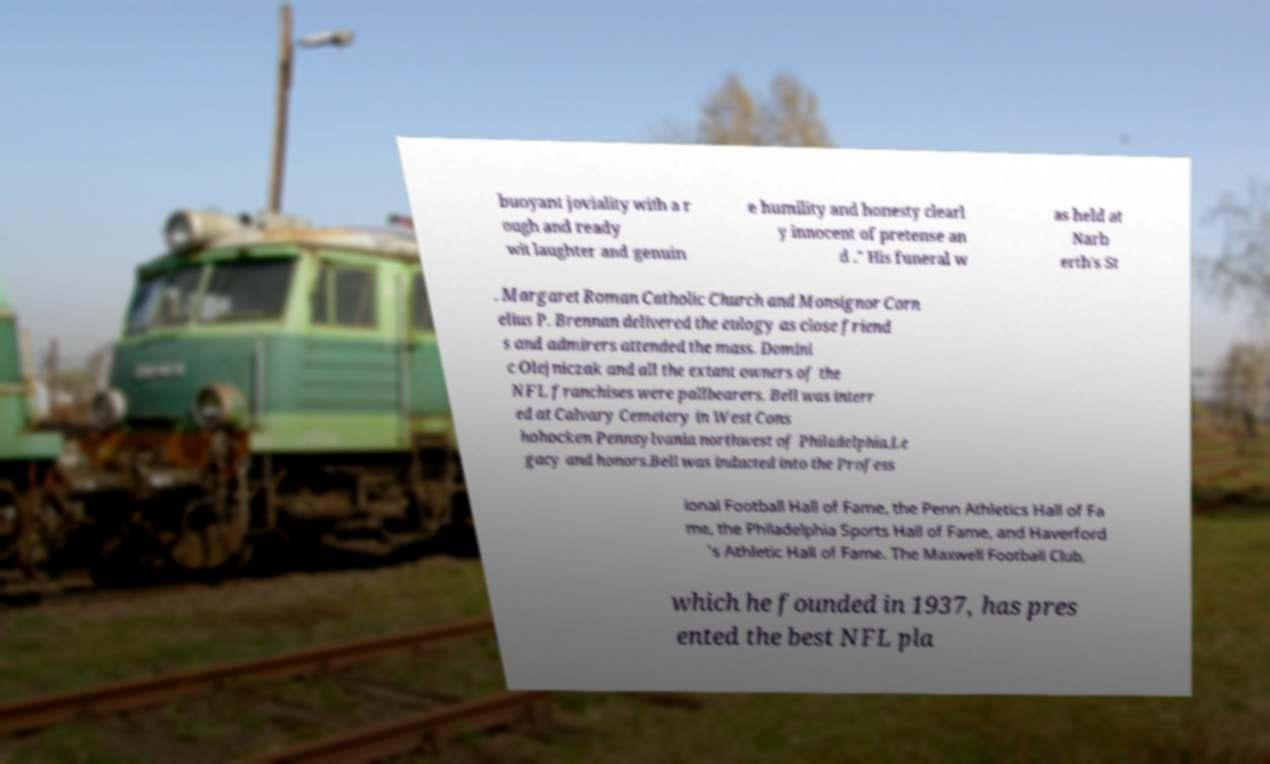Please read and relay the text visible in this image. What does it say? buoyant joviality with a r ough and ready wit laughter and genuin e humility and honesty clearl y innocent of pretense an d ." His funeral w as held at Narb erth's St . Margaret Roman Catholic Church and Monsignor Corn elius P. Brennan delivered the eulogy as close friend s and admirers attended the mass. Domini c Olejniczak and all the extant owners of the NFL franchises were pallbearers. Bell was interr ed at Calvary Cemetery in West Cons hohocken Pennsylvania northwest of Philadelphia.Le gacy and honors.Bell was inducted into the Profess ional Football Hall of Fame, the Penn Athletics Hall of Fa me, the Philadelphia Sports Hall of Fame, and Haverford 's Athletic Hall of Fame. The Maxwell Football Club, which he founded in 1937, has pres ented the best NFL pla 